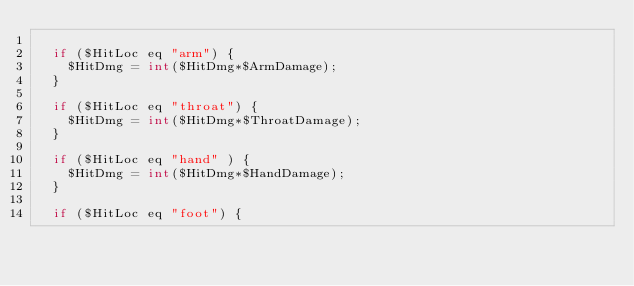<code> <loc_0><loc_0><loc_500><loc_500><_Perl_>
	if ($HitLoc eq "arm") {
		$HitDmg = int($HitDmg*$ArmDamage);
	}

	if ($HitLoc eq "throat") {
		$HitDmg = int($HitDmg*$ThroatDamage);
	}

	if ($HitLoc eq "hand" ) {
		$HitDmg = int($HitDmg*$HandDamage);
	}

	if ($HitLoc eq "foot") {</code> 